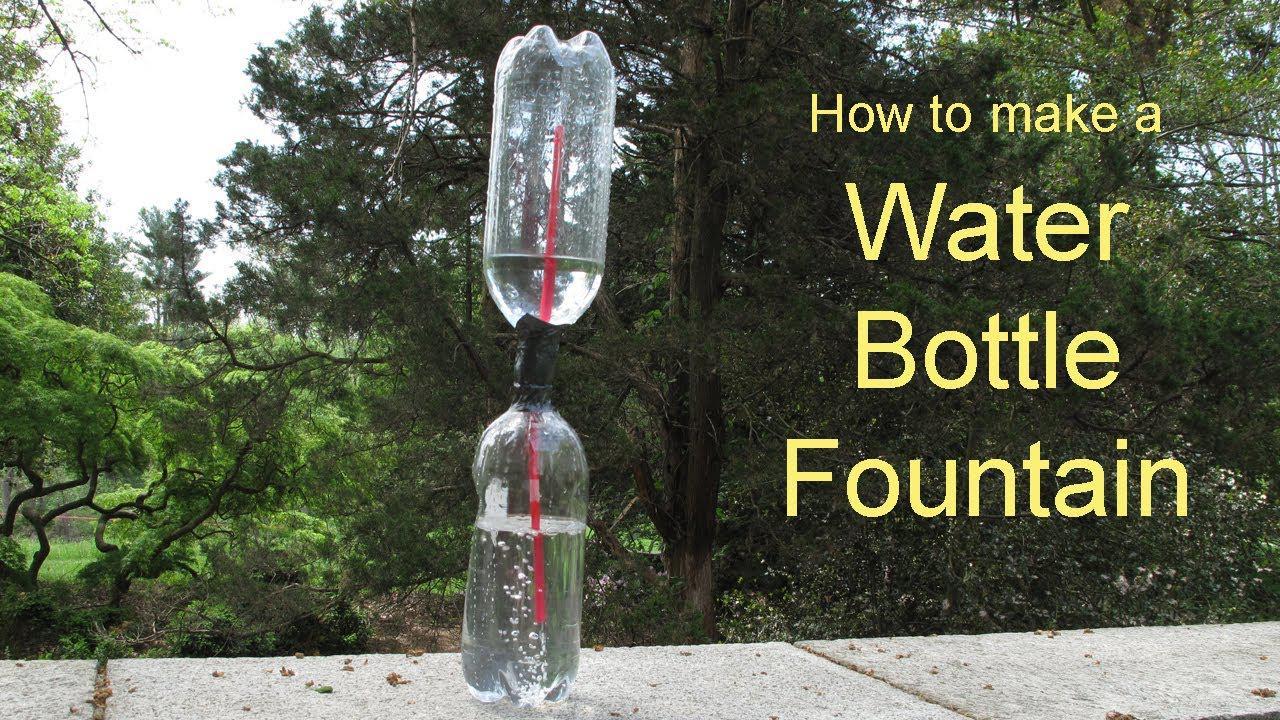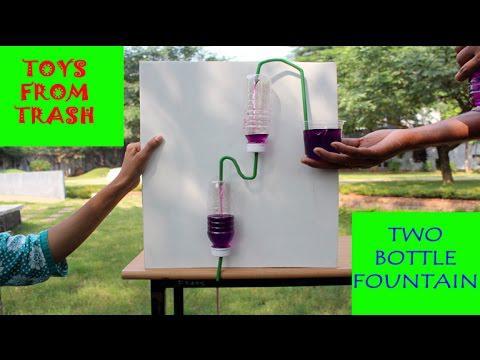The first image is the image on the left, the second image is the image on the right. Considering the images on both sides, is "One of the images features a person demonstrating the fountain." valid? Answer yes or no. Yes. The first image is the image on the left, the second image is the image on the right. For the images shown, is this caption "Each image shows a set-up with purple liquid flowing from the top to the bottom, with blue bottle caps visible in each picture." true? Answer yes or no. No. 